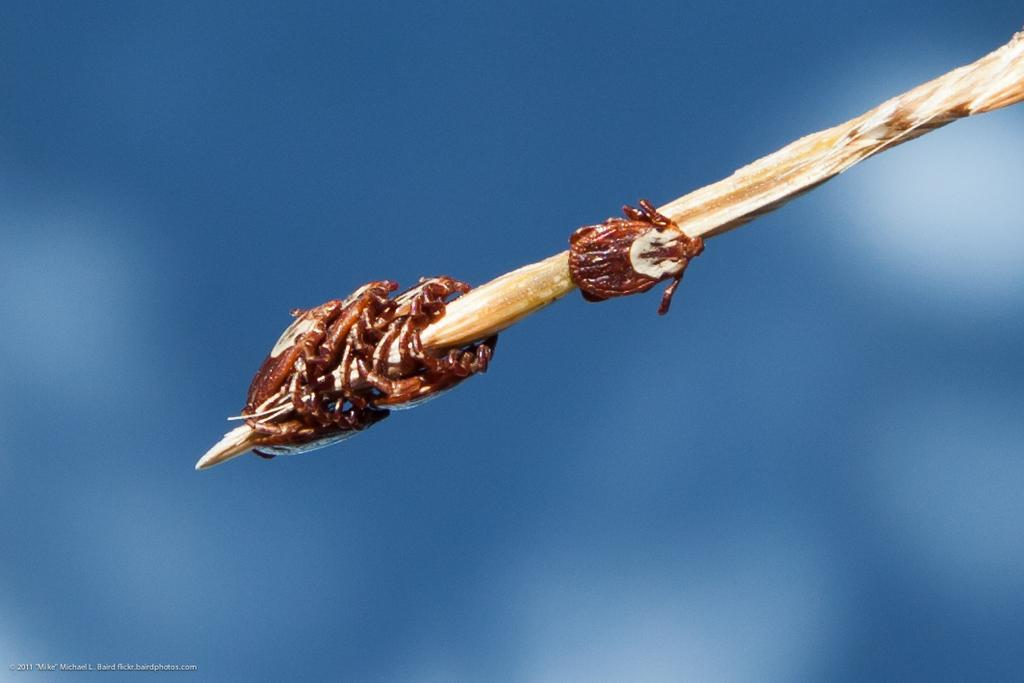What object can be seen in the image? There is a stick in the image. What is present on the stick? There are small insects insects on the stick. What type of trail can be seen near the stick in the image? There is no trail present in the image; it only features a stick with small insects on it. 